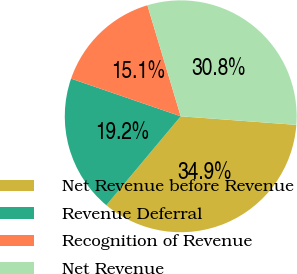Convert chart to OTSL. <chart><loc_0><loc_0><loc_500><loc_500><pie_chart><fcel>Net Revenue before Revenue<fcel>Revenue Deferral<fcel>Recognition of Revenue<fcel>Net Revenue<nl><fcel>34.91%<fcel>19.18%<fcel>15.09%<fcel>30.82%<nl></chart> 